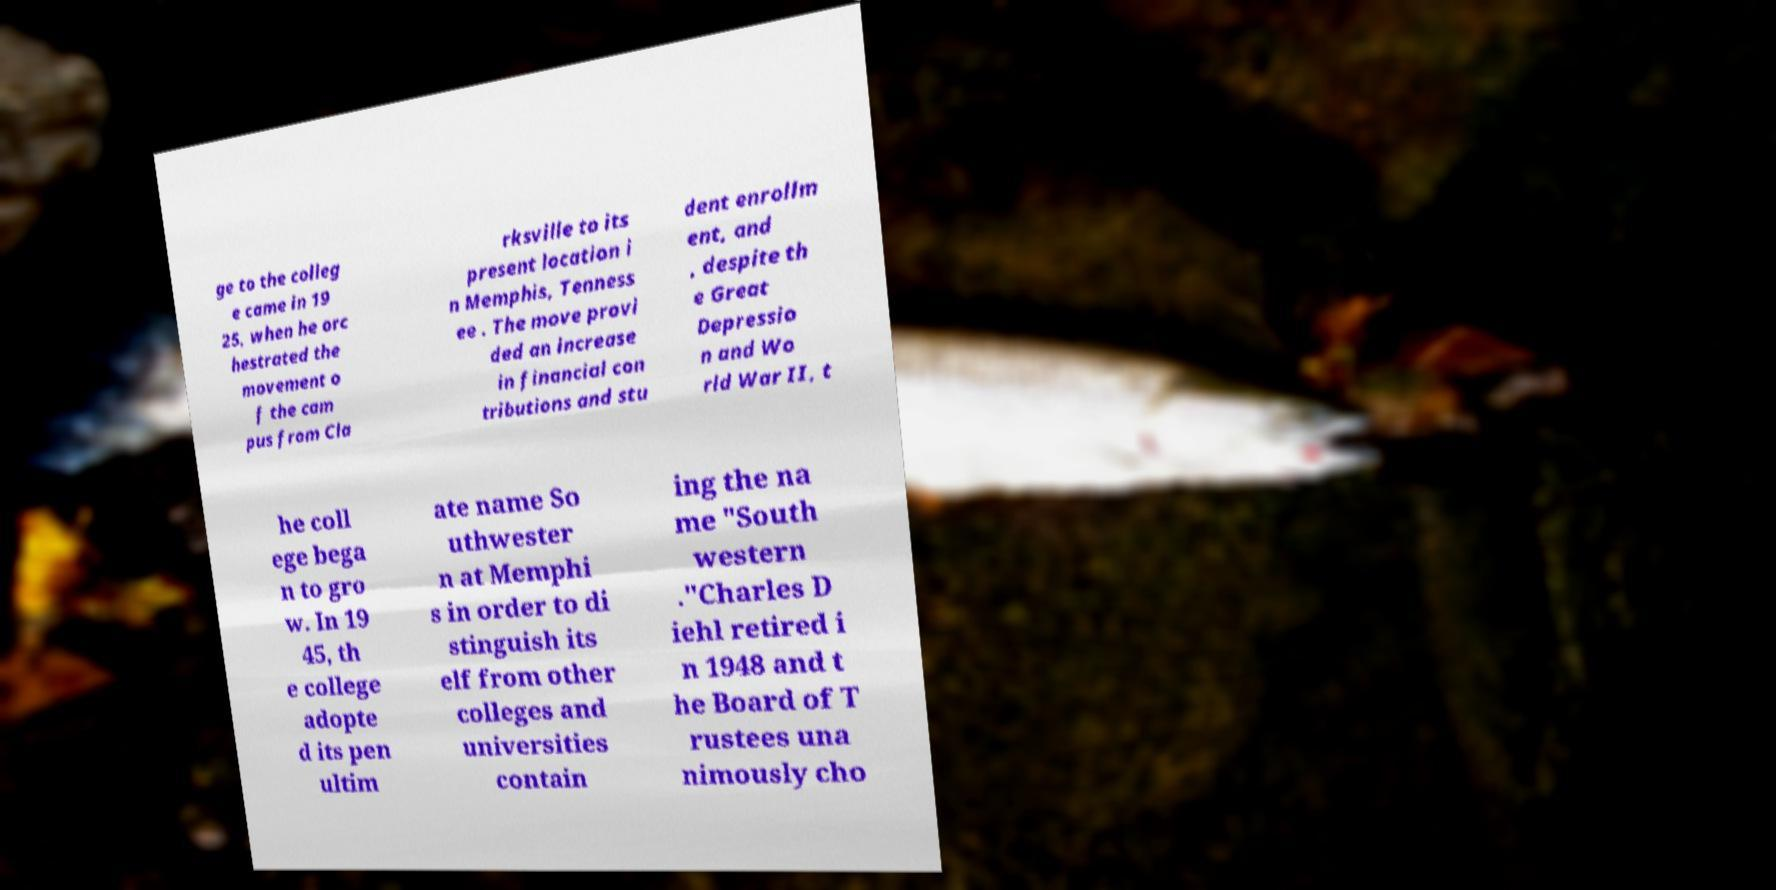For documentation purposes, I need the text within this image transcribed. Could you provide that? ge to the colleg e came in 19 25, when he orc hestrated the movement o f the cam pus from Cla rksville to its present location i n Memphis, Tenness ee . The move provi ded an increase in financial con tributions and stu dent enrollm ent, and , despite th e Great Depressio n and Wo rld War II, t he coll ege bega n to gro w. In 19 45, th e college adopte d its pen ultim ate name So uthwester n at Memphi s in order to di stinguish its elf from other colleges and universities contain ing the na me "South western ."Charles D iehl retired i n 1948 and t he Board of T rustees una nimously cho 